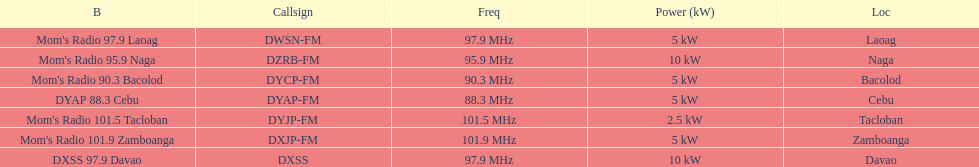What is the last location on this chart? Davao. Can you parse all the data within this table? {'header': ['B', 'Callsign', 'Freq', 'Power (kW)', 'Loc'], 'rows': [["Mom's Radio 97.9 Laoag", 'DWSN-FM', '97.9\xa0MHz', '5\xa0kW', 'Laoag'], ["Mom's Radio 95.9 Naga", 'DZRB-FM', '95.9\xa0MHz', '10\xa0kW', 'Naga'], ["Mom's Radio 90.3 Bacolod", 'DYCP-FM', '90.3\xa0MHz', '5\xa0kW', 'Bacolod'], ['DYAP 88.3 Cebu', 'DYAP-FM', '88.3\xa0MHz', '5\xa0kW', 'Cebu'], ["Mom's Radio 101.5 Tacloban", 'DYJP-FM', '101.5\xa0MHz', '2.5\xa0kW', 'Tacloban'], ["Mom's Radio 101.9 Zamboanga", 'DXJP-FM', '101.9\xa0MHz', '5\xa0kW', 'Zamboanga'], ['DXSS 97.9 Davao', 'DXSS', '97.9\xa0MHz', '10\xa0kW', 'Davao']]} 